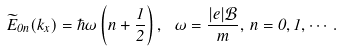<formula> <loc_0><loc_0><loc_500><loc_500>\widetilde { E } _ { 0 n } ( k _ { x } ) = \hbar { \omega } \left ( n + \frac { 1 } { 2 } \right ) , \, \ \omega = \frac { | e | \mathcal { B } } { m } , \, n = 0 , 1 , \cdots .</formula> 